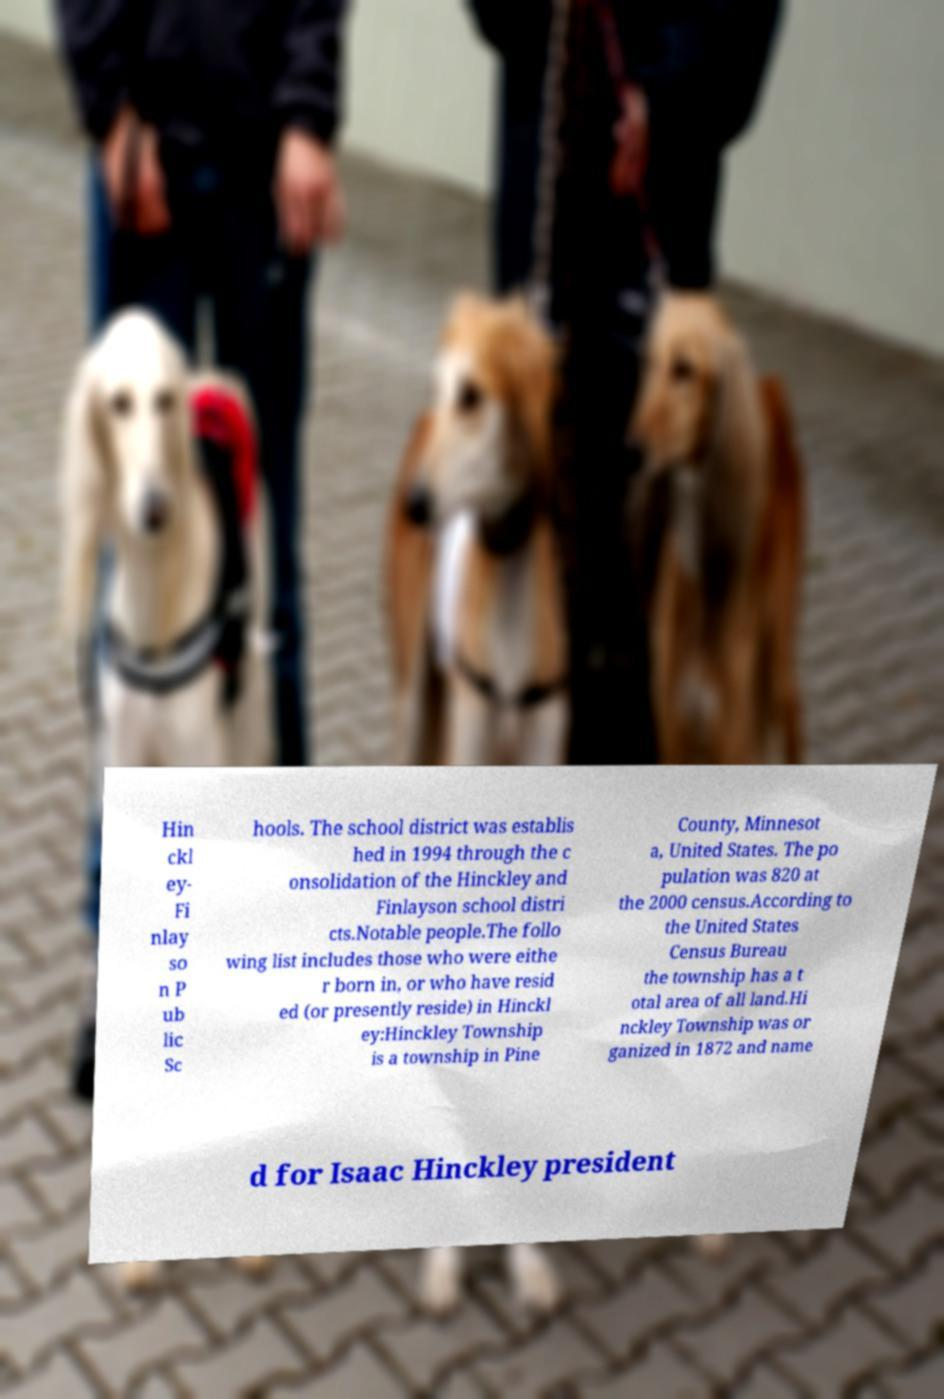Please read and relay the text visible in this image. What does it say? Hin ckl ey- Fi nlay so n P ub lic Sc hools. The school district was establis hed in 1994 through the c onsolidation of the Hinckley and Finlayson school distri cts.Notable people.The follo wing list includes those who were eithe r born in, or who have resid ed (or presently reside) in Hinckl ey:Hinckley Township is a township in Pine County, Minnesot a, United States. The po pulation was 820 at the 2000 census.According to the United States Census Bureau the township has a t otal area of all land.Hi nckley Township was or ganized in 1872 and name d for Isaac Hinckley president 